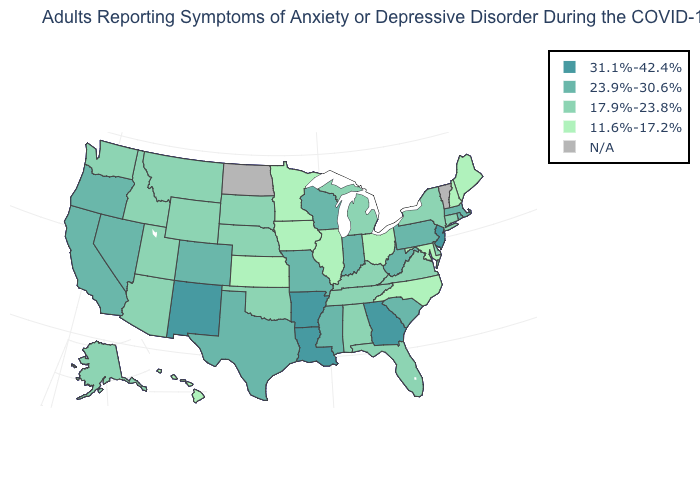What is the value of Massachusetts?
Quick response, please. 23.9%-30.6%. Name the states that have a value in the range 11.6%-17.2%?
Quick response, please. Hawaii, Illinois, Iowa, Kansas, Maine, Maryland, Minnesota, New Hampshire, North Carolina, Ohio. What is the highest value in the USA?
Be succinct. 31.1%-42.4%. What is the lowest value in states that border Oregon?
Be succinct. 17.9%-23.8%. What is the highest value in states that border New Mexico?
Write a very short answer. 23.9%-30.6%. Name the states that have a value in the range N/A?
Write a very short answer. North Dakota, Vermont. Name the states that have a value in the range N/A?
Give a very brief answer. North Dakota, Vermont. Among the states that border Connecticut , does New York have the lowest value?
Be succinct. Yes. Name the states that have a value in the range N/A?
Short answer required. North Dakota, Vermont. Name the states that have a value in the range 23.9%-30.6%?
Concise answer only. California, Colorado, Indiana, Massachusetts, Mississippi, Missouri, Nevada, Oregon, Pennsylvania, Rhode Island, South Carolina, Texas, West Virginia, Wisconsin. Name the states that have a value in the range 31.1%-42.4%?
Answer briefly. Arkansas, Georgia, Louisiana, New Jersey, New Mexico. What is the value of Oregon?
Be succinct. 23.9%-30.6%. Which states hav the highest value in the MidWest?
Short answer required. Indiana, Missouri, Wisconsin. 